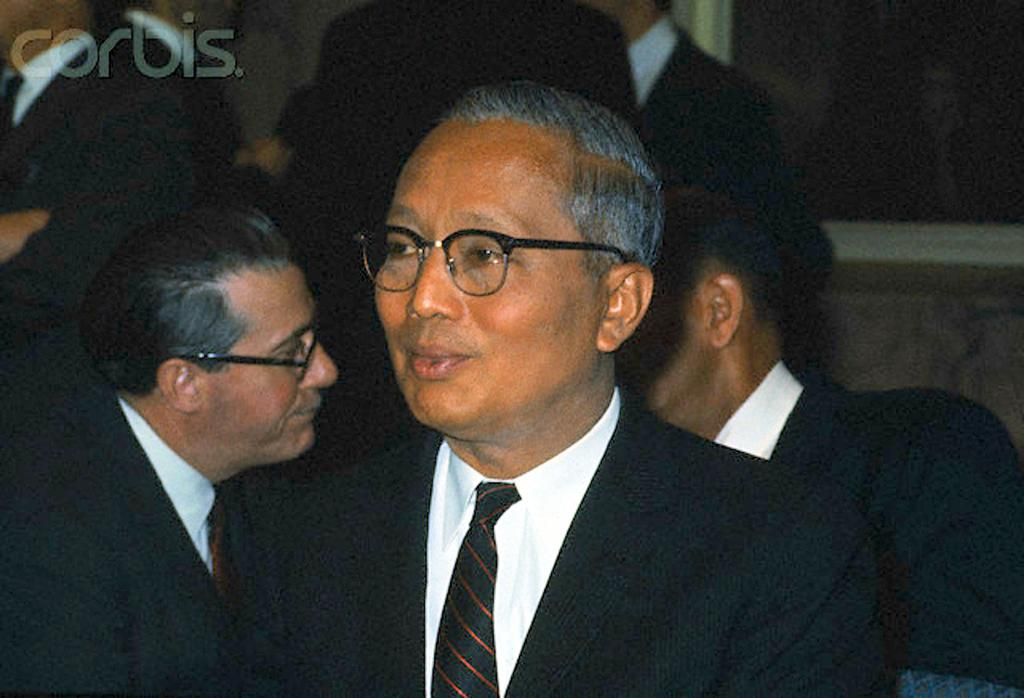How many people are visible in the image? There are many people in the image. What can be seen at the top left corner of the image? There is a watermark at the top left of the image. What architectural feature is present on the right side of the image? There is a window at the right side of the image. What type of hole can be seen in the eye of the person in the image? There is no hole in the eye of any person in the image, nor is there any paper present. 